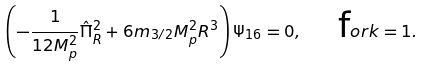Convert formula to latex. <formula><loc_0><loc_0><loc_500><loc_500>\left ( - \frac { 1 } { 1 2 M _ { p } ^ { 2 } } \hat { \Pi } _ { R } ^ { 2 } + 6 m _ { 3 / 2 } M _ { p } ^ { 2 } R ^ { 3 } \right ) \Psi _ { 1 6 } = 0 , \quad { \mbox f o r k = 1 } .</formula> 